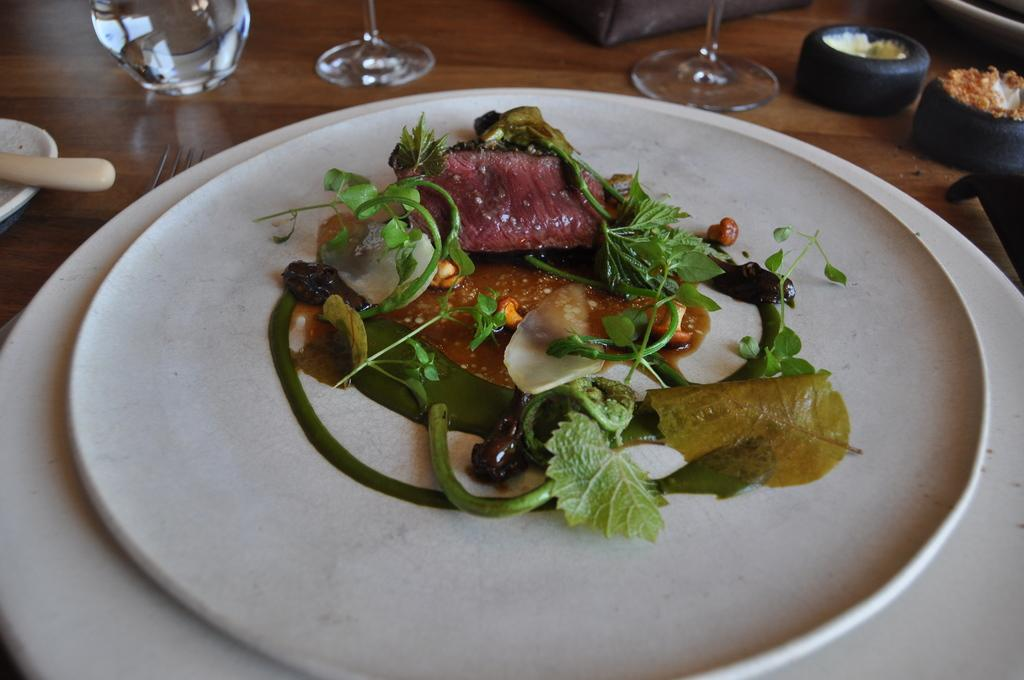What is the main food item visible on the plate in the image? Unfortunately, the specific food item cannot be determined from the provided facts. What type of containers are present in the image? There are glasses in the image. What else can be seen on the table in the image? There are other objects on the table in the image, but their specific nature cannot be determined from the provided facts. Who is the manager of the person in the image? There is no person present in the image, so it is not possible to determine who their manager might be. 